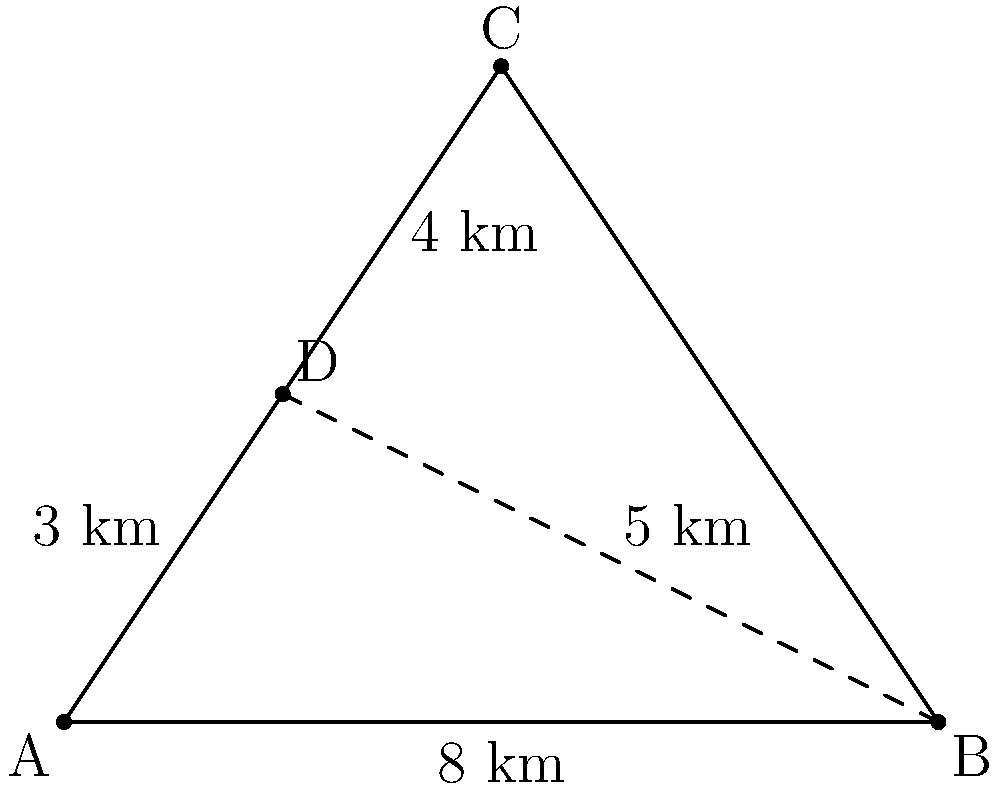A city planner wants to determine the optimal location for a new community center that will serve three neighborhoods (A, B, and C). Using triangulation methods, they've identified a potential location (D) with the following distances:
- D to A: 3 km
- D to B: 5 km
- D to C: 4 km
- A to B: 8 km

Calculate the area of the triangle formed by the three neighborhoods (ABC) to assess the coverage of the community center. Round your answer to the nearest square kilometer. To find the area of triangle ABC, we can use Heron's formula. However, we first need to find the length of AC and BC using the law of cosines.

1. Find angle ADB using the law of cosines:
   $$\cos(ADB) = \frac{3^2 + 5^2 - 8^2}{2(3)(5)} = -0.7$$
   $$ADB = \arccos(-0.7) \approx 2.3562 \text{ radians}$$

2. Find AC using the law of cosines:
   $$AC^2 = 3^2 + 4^2 - 2(3)(4)\cos(2.3562)$$
   $$AC \approx 6.3246 \text{ km}$$

3. Find BC using the law of cosines:
   $$BC^2 = 5^2 + 4^2 - 2(5)(4)\cos(2.3562)$$
   $$BC \approx 7.2111 \text{ km}$$

4. Use Heron's formula to calculate the area:
   $$s = \frac{a + b + c}{2} = \frac{8 + 6.3246 + 7.2111}{2} \approx 10.7679$$
   $$\text{Area} = \sqrt{s(s-a)(s-b)(s-c)}$$
   $$\text{Area} = \sqrt{10.7679(10.7679-8)(10.7679-6.3246)(10.7679-7.2111)}$$
   $$\text{Area} \approx 23.9821 \text{ km}^2$$

5. Rounding to the nearest square kilometer:
   $$\text{Area} \approx 24 \text{ km}^2$$
Answer: 24 km² 